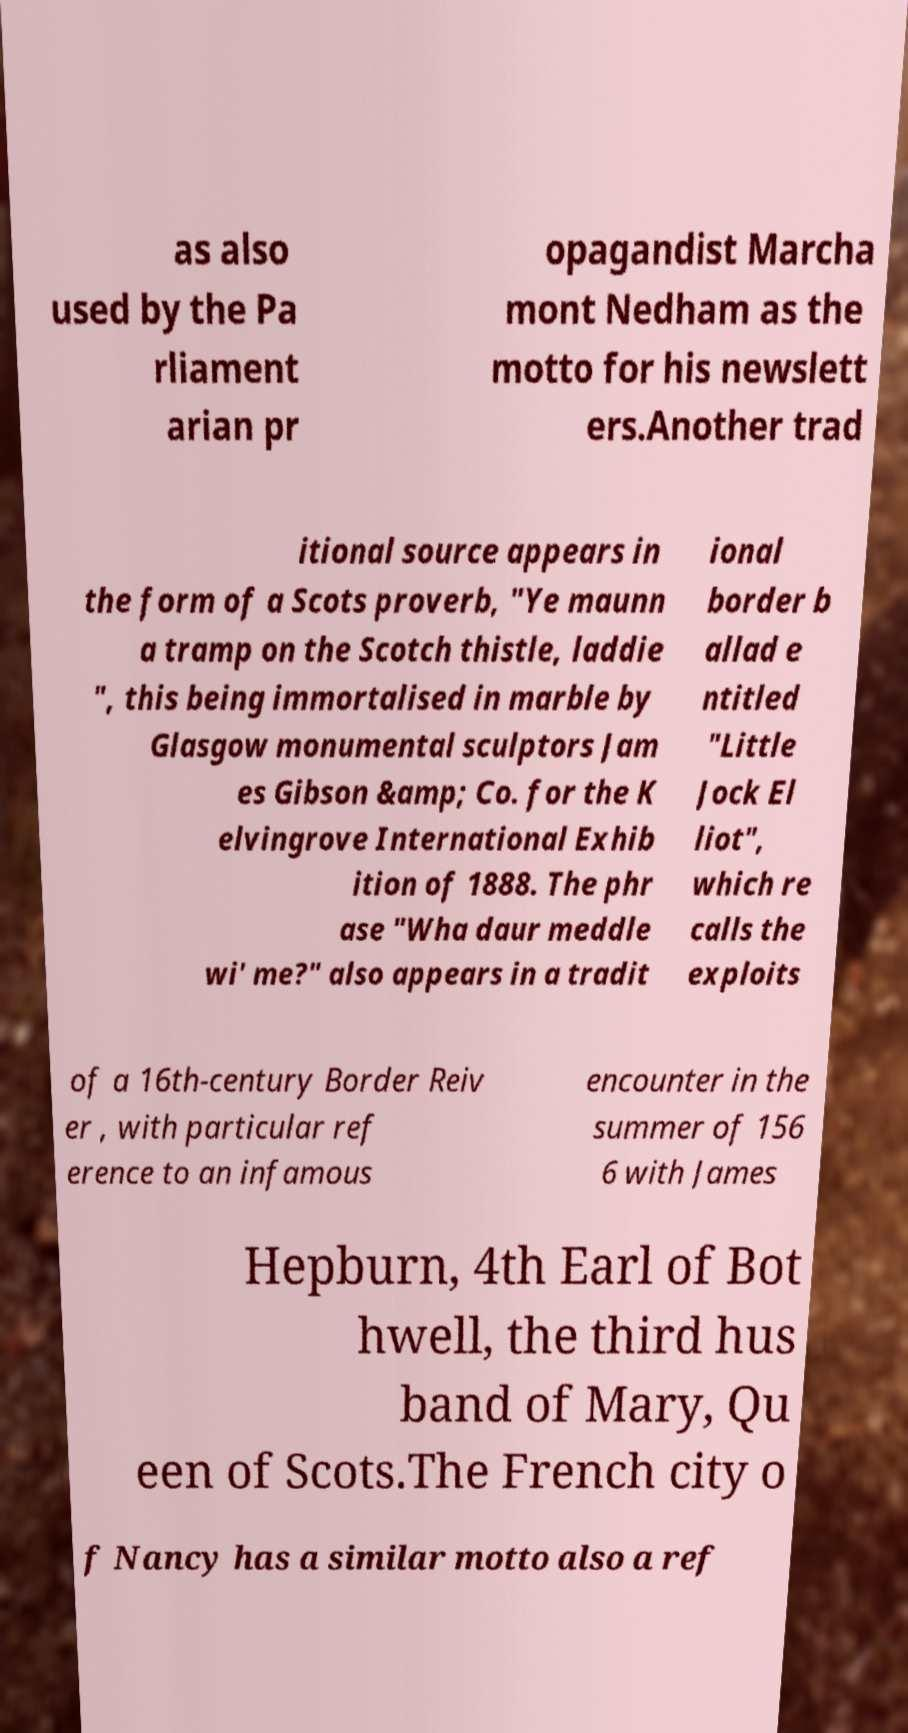Please identify and transcribe the text found in this image. as also used by the Pa rliament arian pr opagandist Marcha mont Nedham as the motto for his newslett ers.Another trad itional source appears in the form of a Scots proverb, "Ye maunn a tramp on the Scotch thistle, laddie ", this being immortalised in marble by Glasgow monumental sculptors Jam es Gibson &amp; Co. for the K elvingrove International Exhib ition of 1888. The phr ase "Wha daur meddle wi' me?" also appears in a tradit ional border b allad e ntitled "Little Jock El liot", which re calls the exploits of a 16th-century Border Reiv er , with particular ref erence to an infamous encounter in the summer of 156 6 with James Hepburn, 4th Earl of Bot hwell, the third hus band of Mary, Qu een of Scots.The French city o f Nancy has a similar motto also a ref 